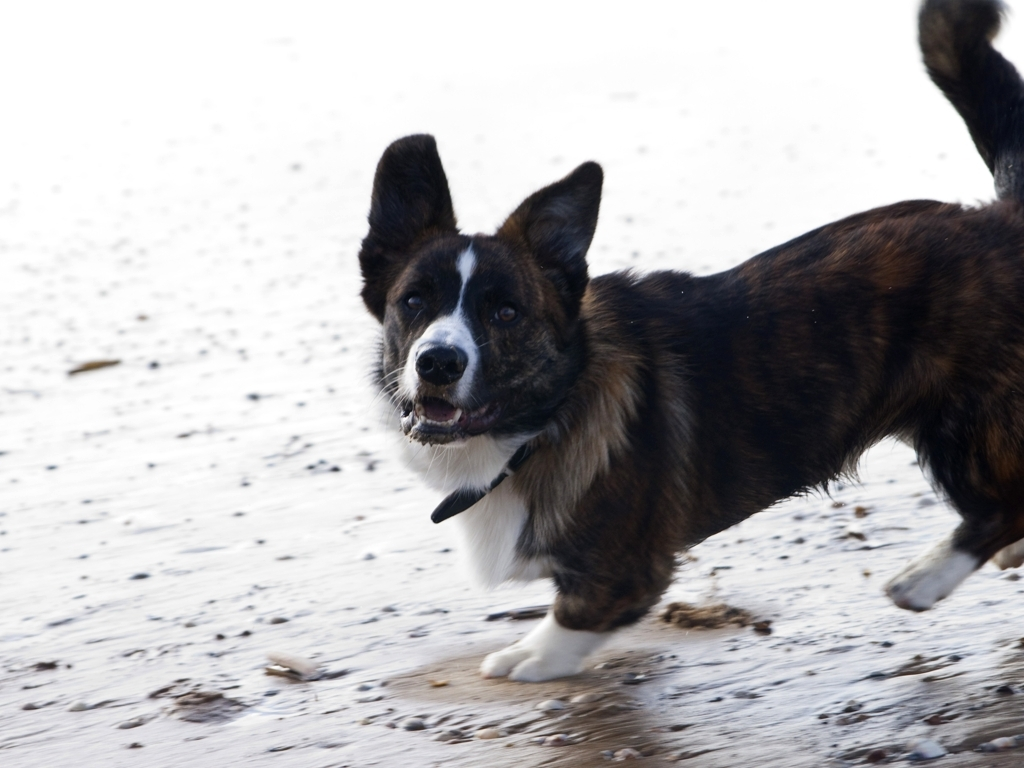What breed is this dog, and what are some characteristic features? This dog seems to be a Cardigan Welsh Corgi, characterized by its medium-sized body, long tail, and large, upright ears. Its coat pattern includes distinct coloration with darker and lighter brown shades. 